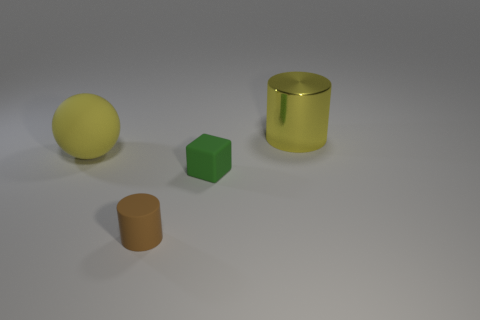Is the number of small rubber things that are left of the tiny brown thing the same as the number of matte objects that are behind the big yellow sphere?
Keep it short and to the point. Yes. What is the shape of the big yellow thing that is on the left side of the large yellow thing behind the yellow ball?
Give a very brief answer. Sphere. Is there a red rubber object of the same shape as the brown thing?
Provide a succinct answer. No. What number of rubber things are there?
Provide a short and direct response. 3. Are the large yellow thing that is on the left side of the yellow metal thing and the tiny green cube made of the same material?
Give a very brief answer. Yes. Are there any rubber cylinders that have the same size as the yellow rubber thing?
Make the answer very short. No. There is a small brown rubber thing; is its shape the same as the large object that is to the right of the big yellow rubber ball?
Give a very brief answer. Yes. There is a cylinder that is in front of the large yellow object on the right side of the small brown rubber thing; are there any tiny green blocks that are in front of it?
Your answer should be very brief. No. What is the size of the yellow rubber thing?
Give a very brief answer. Large. What number of other things are there of the same color as the metallic object?
Make the answer very short. 1. 